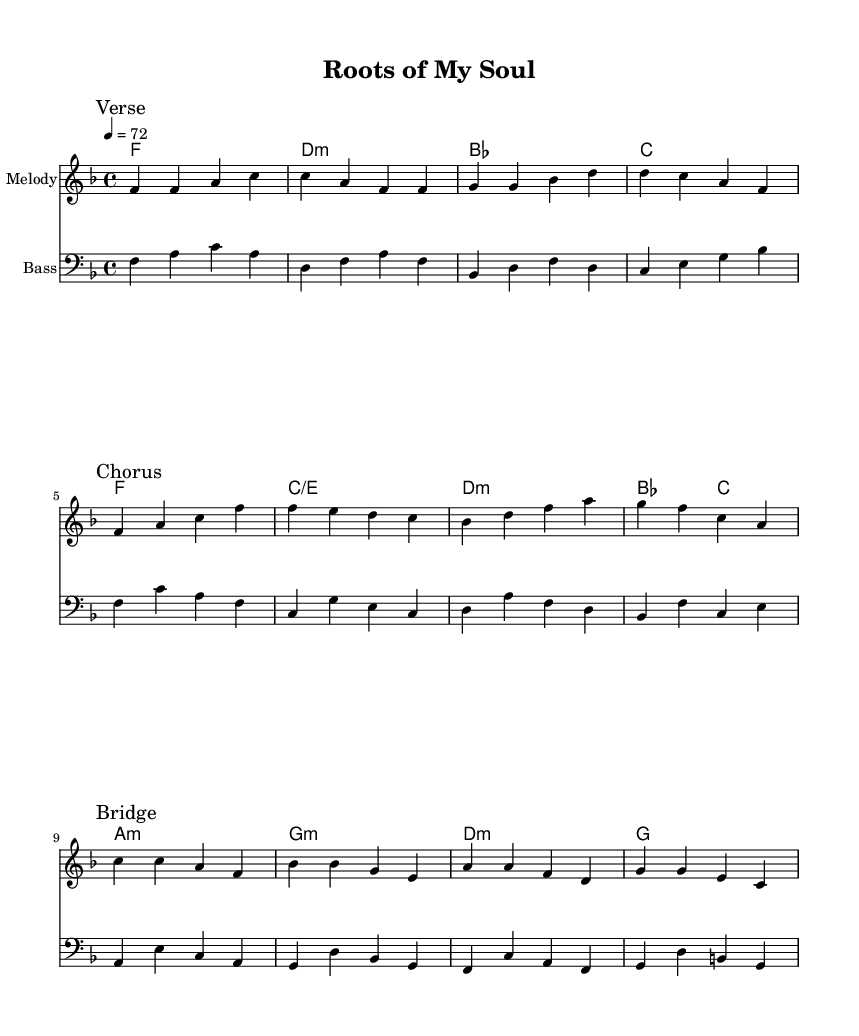What is the key signature of this music? The key signature is F major, which has one flat (B flat). This can be determined by looking at the key signature indicated at the beginning of the staff.
Answer: F major What is the time signature of this piece? The time signature is 4/4, as noted at the beginning of the score. This means there are four beats in a measure and each quarter note gets one beat.
Answer: 4/4 What is the tempo marking for the piece? The tempo marking is 72 beats per minute, indicated by the '4 = 72' in the header. This tempo indicates the speed of the piece.
Answer: 72 How many measures are in the melody section? There are 12 measures in the melody section from the beginning of the piece until the end of the Chorus. Counting the bars carefully shows there are 12 distinct measures.
Answer: 12 Which section comes after the verse in the song structure? The section that comes after the verse is the chorus, as indicated by the markings "Verse" and "Chorus" in the music. The song structure clearly labels these transitions.
Answer: Chorus How many chords are used in the harmony section? There are eight distinct chords used in the harmony section, as listed in sequence with each change. Counting each chord in the harmonic progression provides this number.
Answer: 8 What is the first note of the bridge section? The first note of the bridge section is C. This can be found by looking at the beginning of the "Bridge" mark and noting the first note in that part of the melody.
Answer: C 